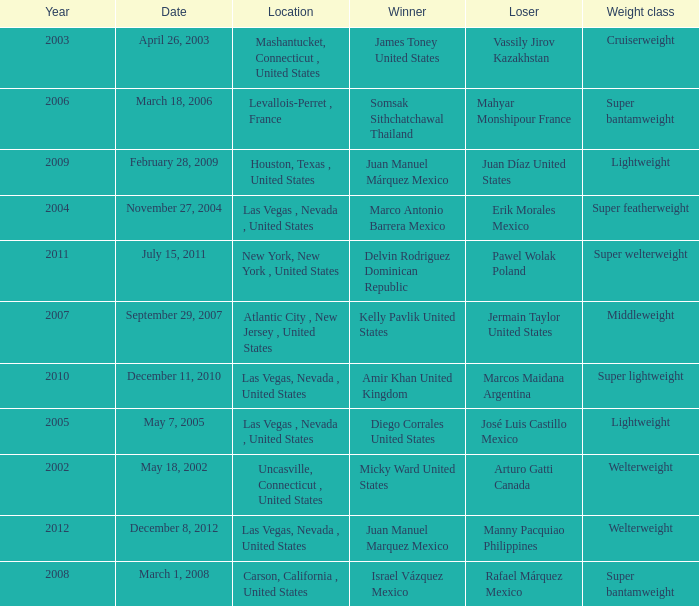How many years were lightweight class on february 28, 2009? 1.0. 